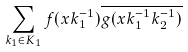<formula> <loc_0><loc_0><loc_500><loc_500>\sum _ { k _ { 1 } \in K _ { 1 } } f ( x k _ { 1 } ^ { - 1 } ) \overline { g ( x k _ { 1 } ^ { - 1 } k _ { 2 } ^ { - 1 } ) }</formula> 